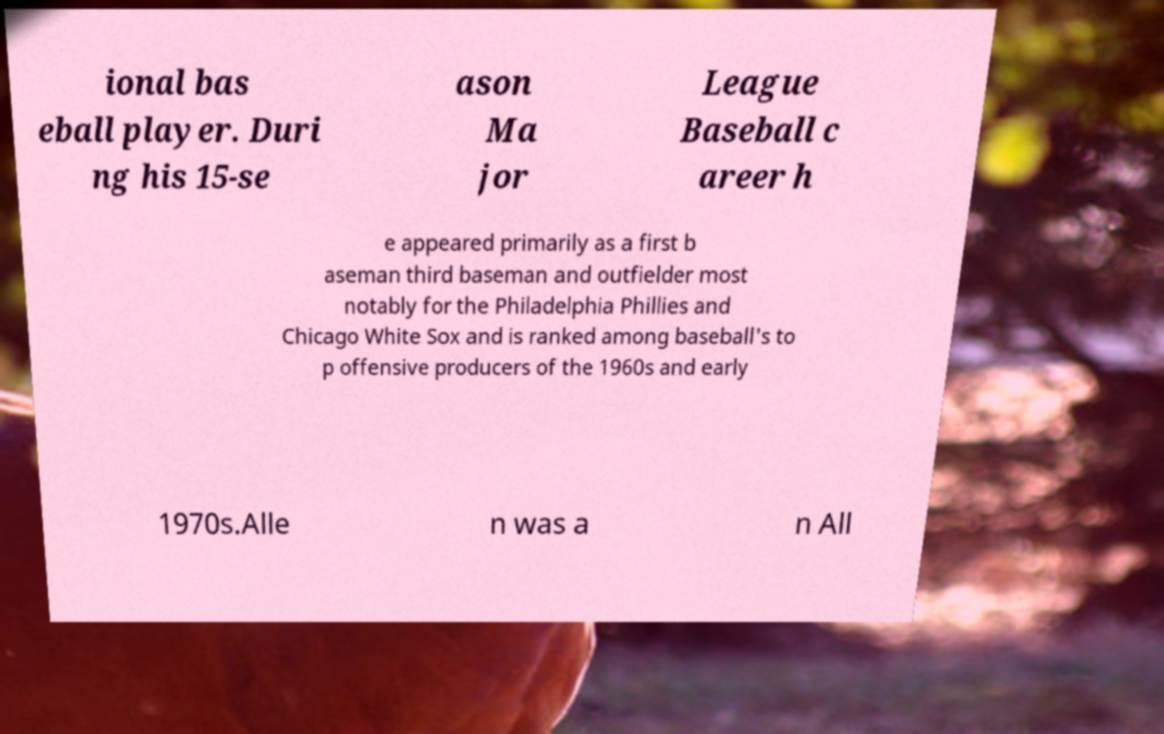There's text embedded in this image that I need extracted. Can you transcribe it verbatim? ional bas eball player. Duri ng his 15-se ason Ma jor League Baseball c areer h e appeared primarily as a first b aseman third baseman and outfielder most notably for the Philadelphia Phillies and Chicago White Sox and is ranked among baseball's to p offensive producers of the 1960s and early 1970s.Alle n was a n All 